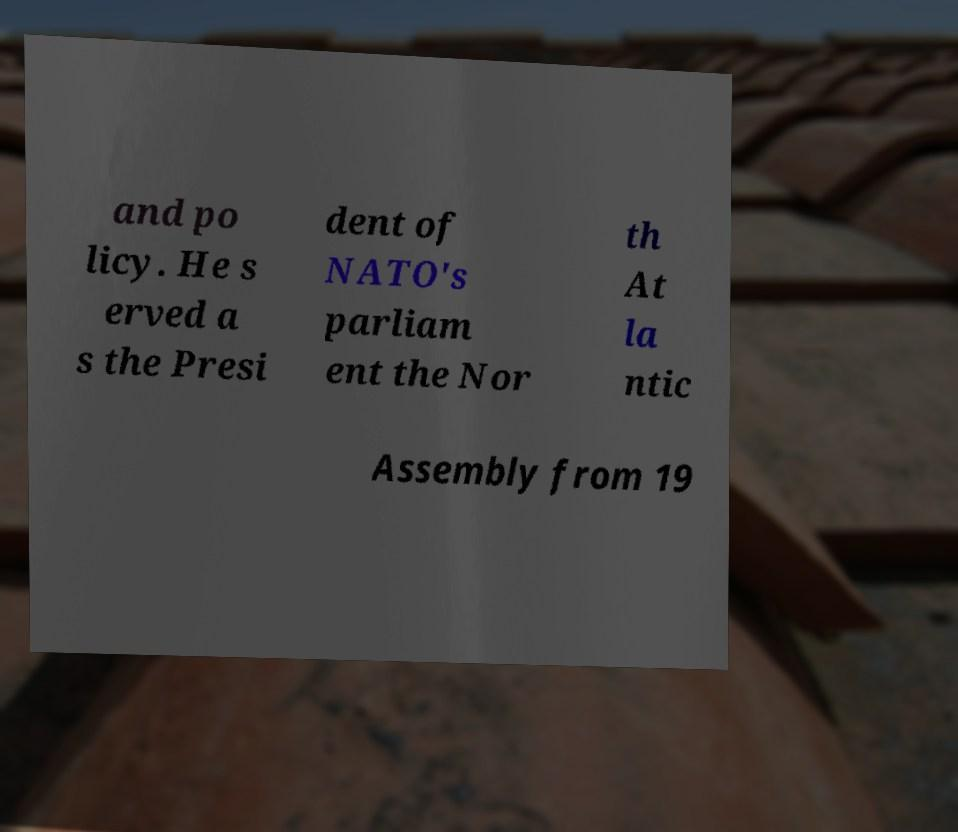For documentation purposes, I need the text within this image transcribed. Could you provide that? and po licy. He s erved a s the Presi dent of NATO's parliam ent the Nor th At la ntic Assembly from 19 